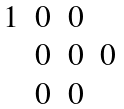Convert formula to latex. <formula><loc_0><loc_0><loc_500><loc_500>\begin{matrix} 1 & 0 & 0 & \\ & 0 & 0 & 0 \\ & 0 & 0 & \end{matrix}</formula> 